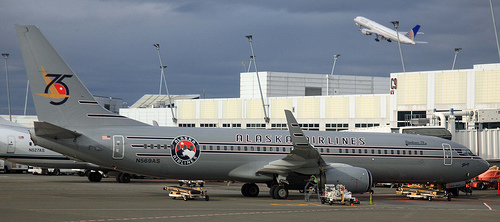Does the door look open? No, the boarding door on the side of the airplane is in the closed position, likely indicating that boarding or deplaning is not currently in process. 